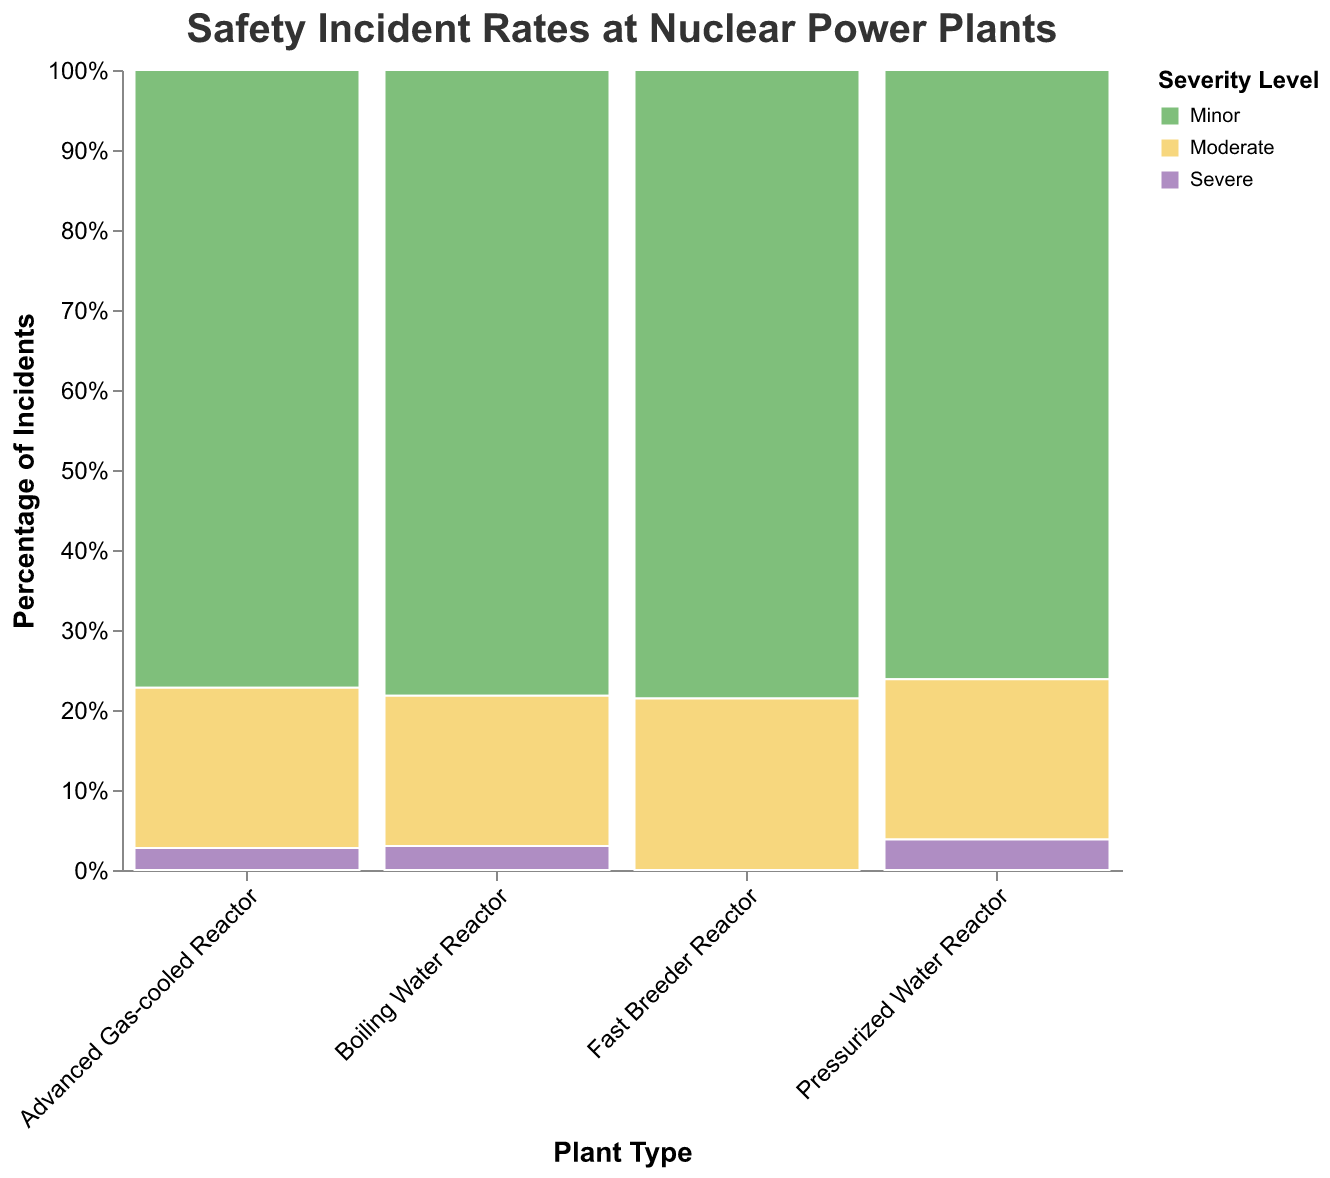What is the total number of incidents for Pressurized Water Reactors? To determine this, sum the incident counts for Minor (42), Moderate (15), and Severe (3) levels for the Pressurized Water Reactor. 42 + 15 + 3 = 60
Answer: 60 Which plant type has the highest percentage of Minor incidents? Compare the heights of the Minor bars (green) across all plant types. Pressurized Water Reactors have the tallest green bar, indicating they have the highest percentage of Minor incidents.
Answer: Pressurized Water Reactor What is the percentage of Moderate incidents in Boiling Water Reactors? The Moderate segment for Boiling Water Reactors (yellow) occupies a certain percentage of the total height. Divide the number of Moderate incidents (12) by the total number of incidents in Boiling Water Reactors (52) and convert to a percentage. 12 / 52 ≈ 0.23, or 23%.
Answer: 23% How many Severe incidents are reported for Advanced Gas-cooled Reactors? Locate the Severe level for Advanced Gas-cooled Reactors. There is a total of 1 Severe incident.
Answer: 1 Compare the total number of incidents between Fast Breeder Reactors and Boiling Water Reactors. Which one has more incidents? Sum the incidents for Fast Breeder Reactors (Minor: 8, Moderate: 3, Severe: 0) and for Boiling Water Reactors (Minor: 38, Moderate: 12, Severe: 2). Fast Breeder Reactors: 8 + 3 + 0 = 11; Boiling Water Reactors: 38 + 12 + 2 = 52. Boiling Water Reactors have more incidents.
Answer: Boiling Water Reactors Is the percentage of Severe incidents greater for Pressurized Water Reactors or Boiling Water Reactors? Calculate the percentages: Pressurized Water Reactors have 3 Severe incidents out of 60 total, so 3/60 = 5%. Boiling Water Reactors have 2 Severe incidents out of 52, so 2/52 ≈ 3.8%. Pressurized Water Reactors have a higher percentage.
Answer: Pressurized Water Reactors Which severity level has the least incidents across all plant types? Compare the total incidents for each severity level across all plants: Minor (108), Moderate (37), Severe (6). Severe has the least.
Answer: Severe What is the combined percentage of Minor and Moderate incidents for Advanced Gas-cooled Reactors? Combine the percentages of Minor (20/28 ≈ 71.4%) and Moderate (7/28 ≈ 25%) incidents. 71.4% + 25% ≈ 96.4%.
Answer: 96.4% Are there any plant types with zero Severe incidents? Inspect the Severe segment for all plant types; Fast Breeder Reactors have zero Severe incidents.
Answer: Fast Breeder Reactor 